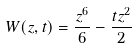Convert formula to latex. <formula><loc_0><loc_0><loc_500><loc_500>W ( z , t ) = \frac { z ^ { 6 } } { 6 } - \frac { t z ^ { 2 } } { 2 }</formula> 